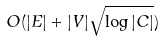Convert formula to latex. <formula><loc_0><loc_0><loc_500><loc_500>O ( | E | + | V | \sqrt { \log | C | } )</formula> 